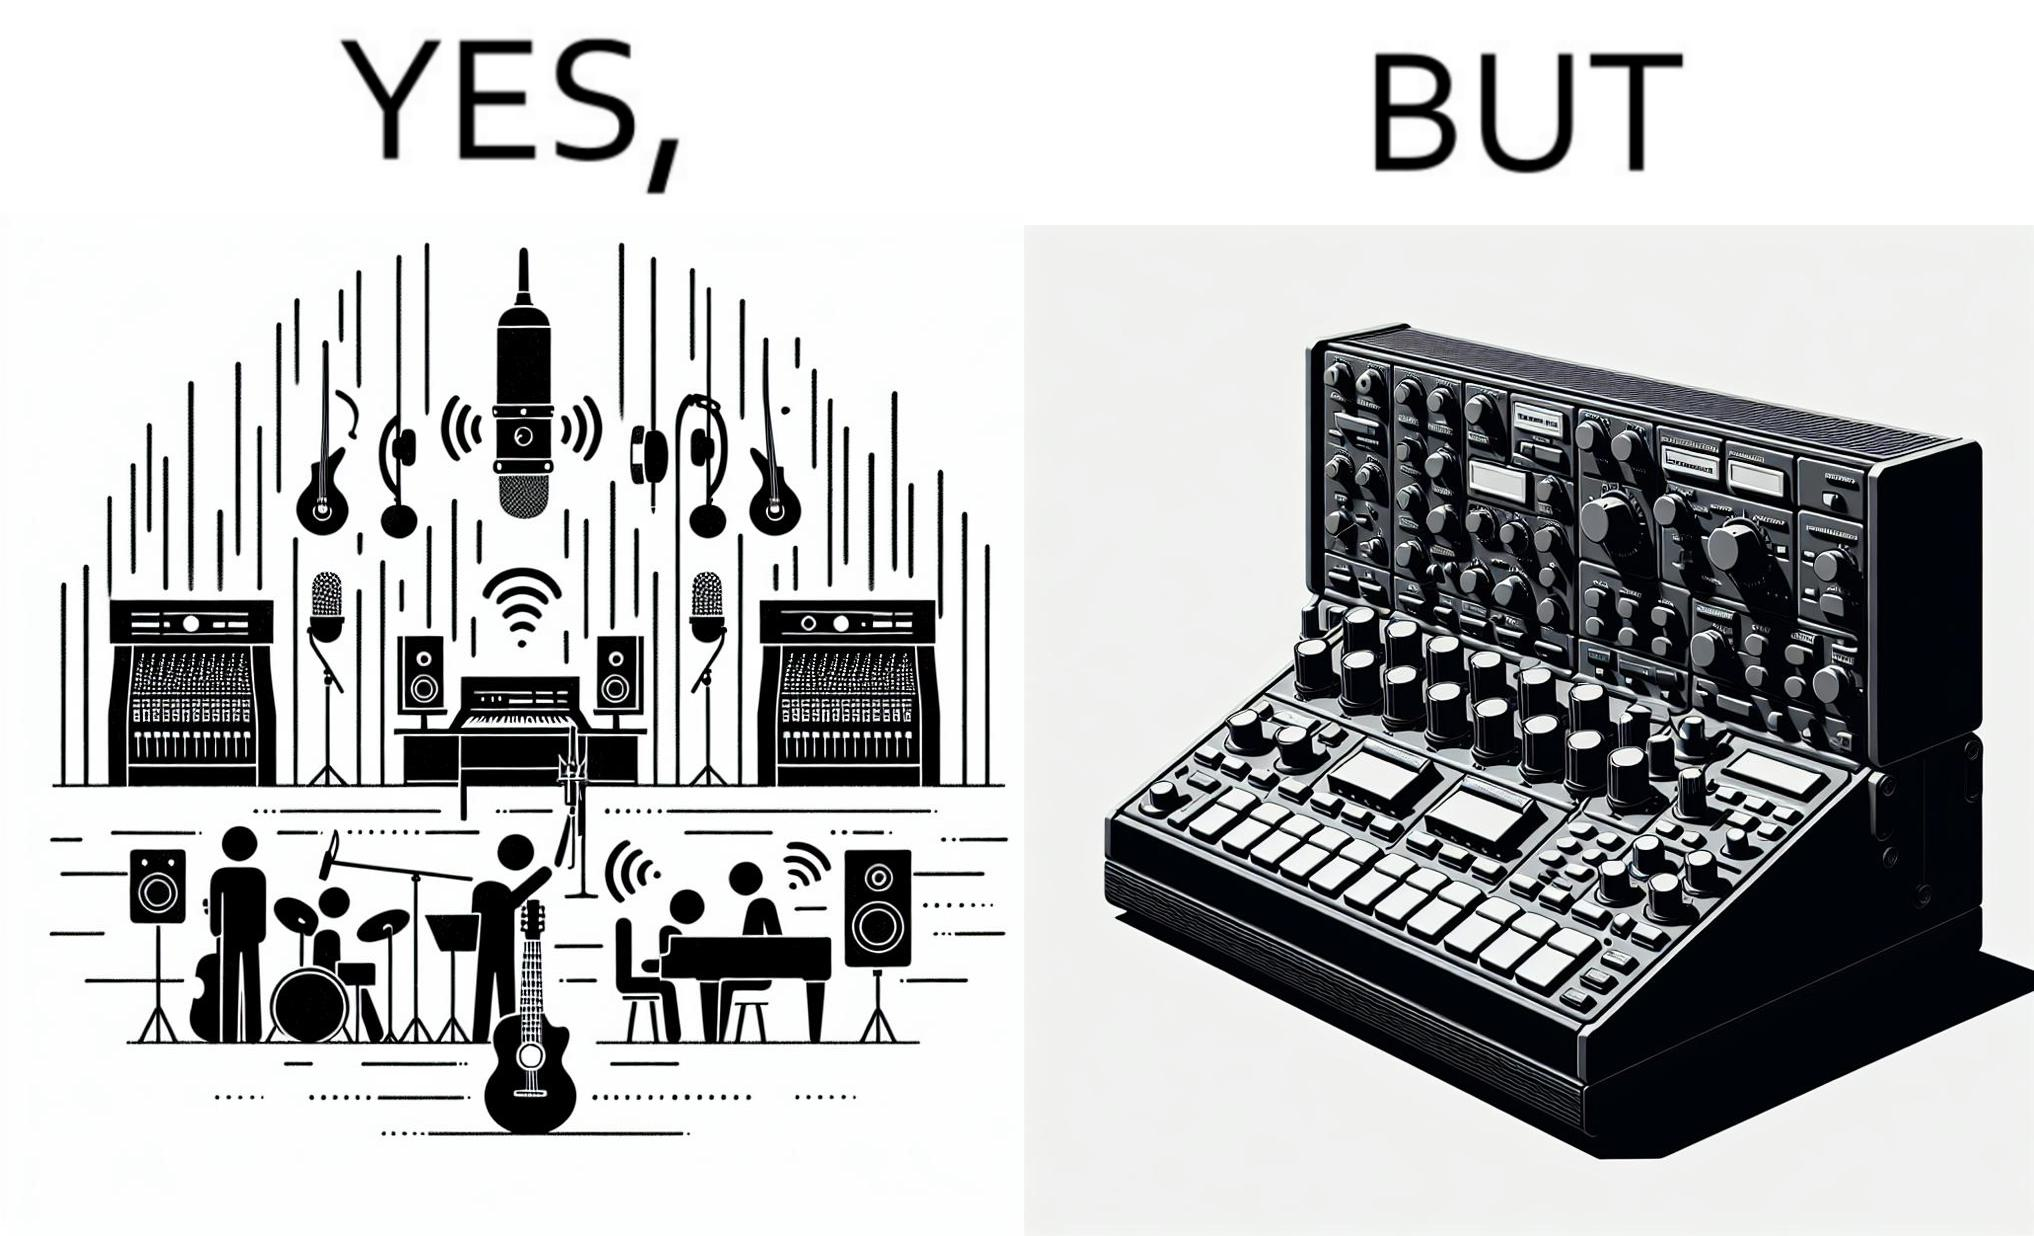Explain why this image is satirical. The image overall is funny because even though people have great music studios and instruments to create and record music, they use electronic replacements of the musical instruments to achieve the task. 